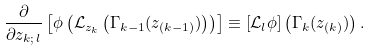<formula> <loc_0><loc_0><loc_500><loc_500>\frac { \partial } { \partial z _ { k ; \, l } } \left [ \phi \left ( \mathcal { L } _ { z _ { k } } \left ( \Gamma _ { k - 1 } ( z _ { ( k - 1 ) } ) \right ) \right ) \right ] \equiv \left [ \mathcal { L } _ { l } \phi \right ] \left ( \Gamma _ { k } ( z _ { ( k ) } ) \right ) .</formula> 